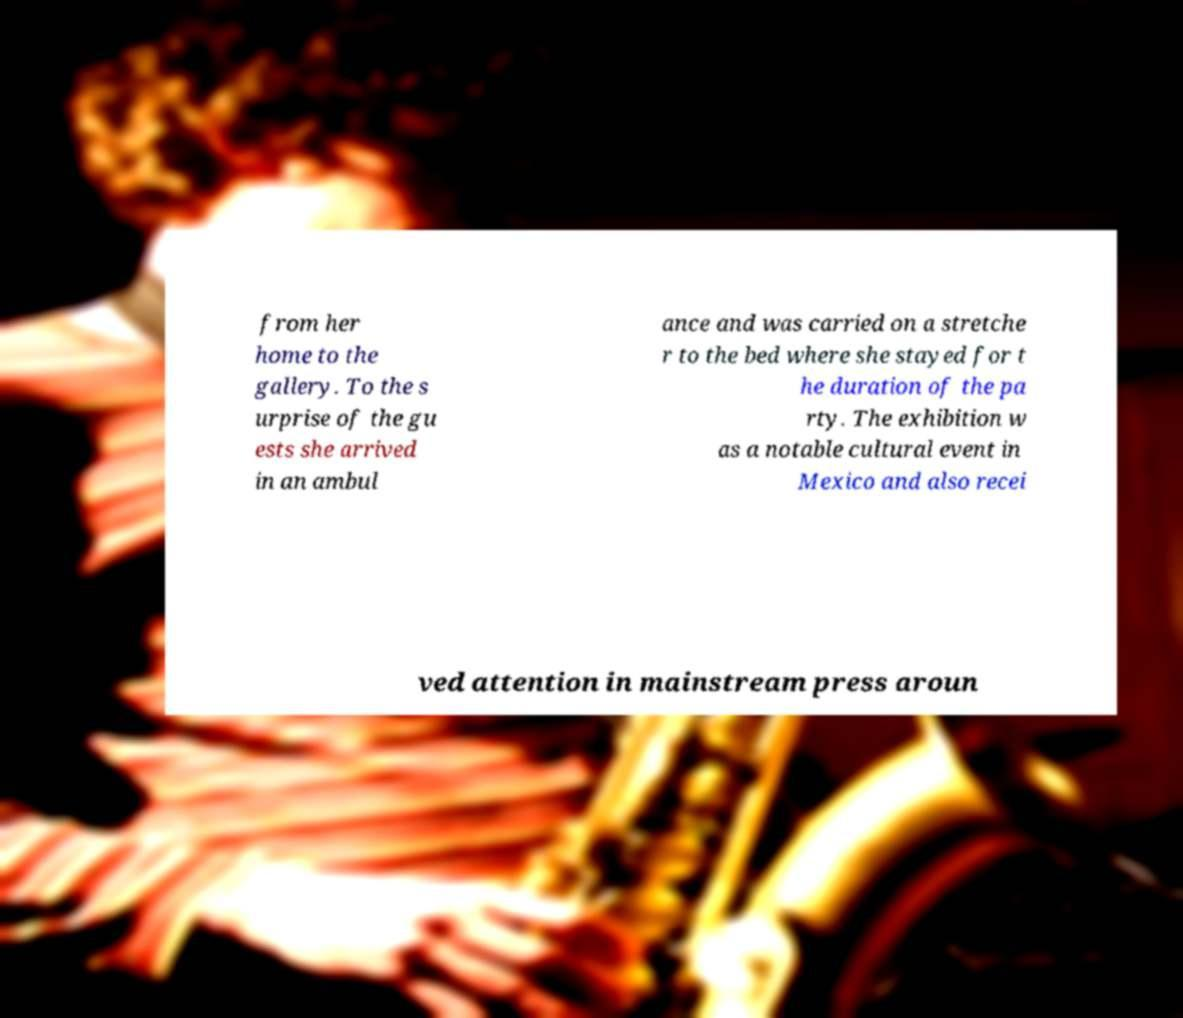Could you assist in decoding the text presented in this image and type it out clearly? from her home to the gallery. To the s urprise of the gu ests she arrived in an ambul ance and was carried on a stretche r to the bed where she stayed for t he duration of the pa rty. The exhibition w as a notable cultural event in Mexico and also recei ved attention in mainstream press aroun 